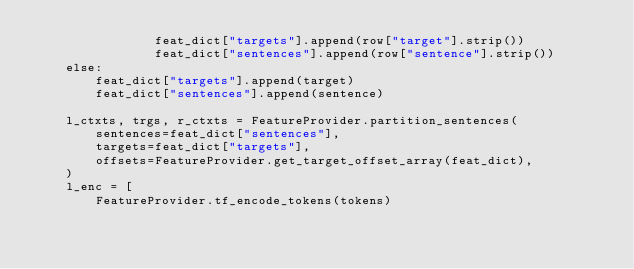Convert code to text. <code><loc_0><loc_0><loc_500><loc_500><_Python_>                feat_dict["targets"].append(row["target"].strip())
                feat_dict["sentences"].append(row["sentence"].strip())
    else:
        feat_dict["targets"].append(target)
        feat_dict["sentences"].append(sentence)

    l_ctxts, trgs, r_ctxts = FeatureProvider.partition_sentences(
        sentences=feat_dict["sentences"],
        targets=feat_dict["targets"],
        offsets=FeatureProvider.get_target_offset_array(feat_dict),
    )
    l_enc = [
        FeatureProvider.tf_encode_tokens(tokens)</code> 